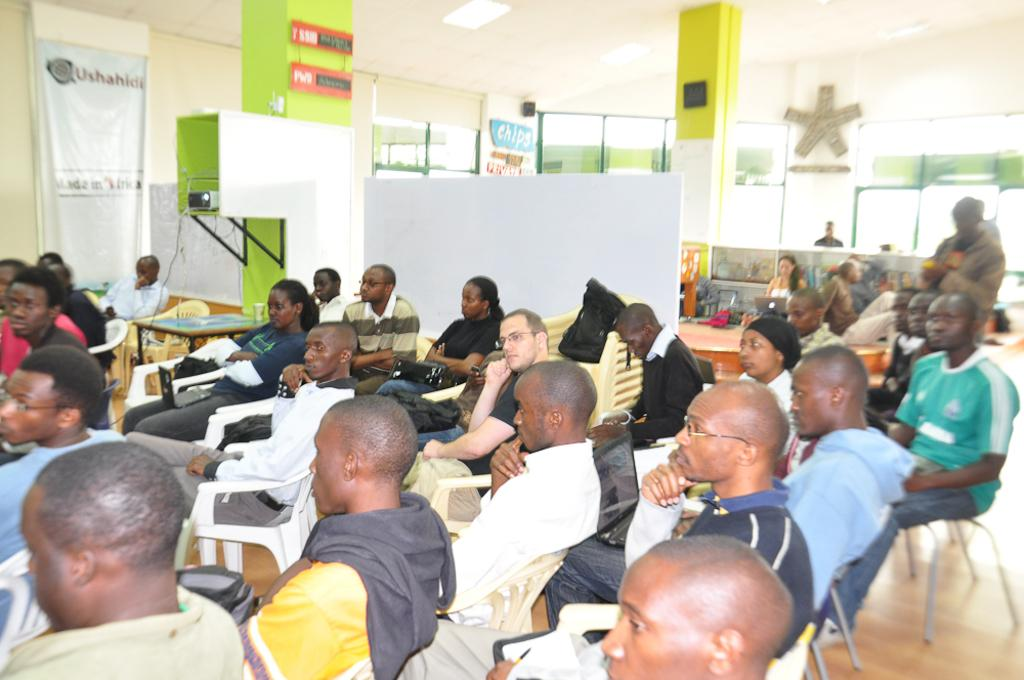Who or what can be seen in the image? There are people in the image. What are the people doing in the image? The people are sitting on chairs. What other objects or structures are present in the image? There is a pillar in the image. What type of magic is being performed by the people in the image? There is no indication of magic or any magical activity in the image. The people are simply sitting on chairs. 